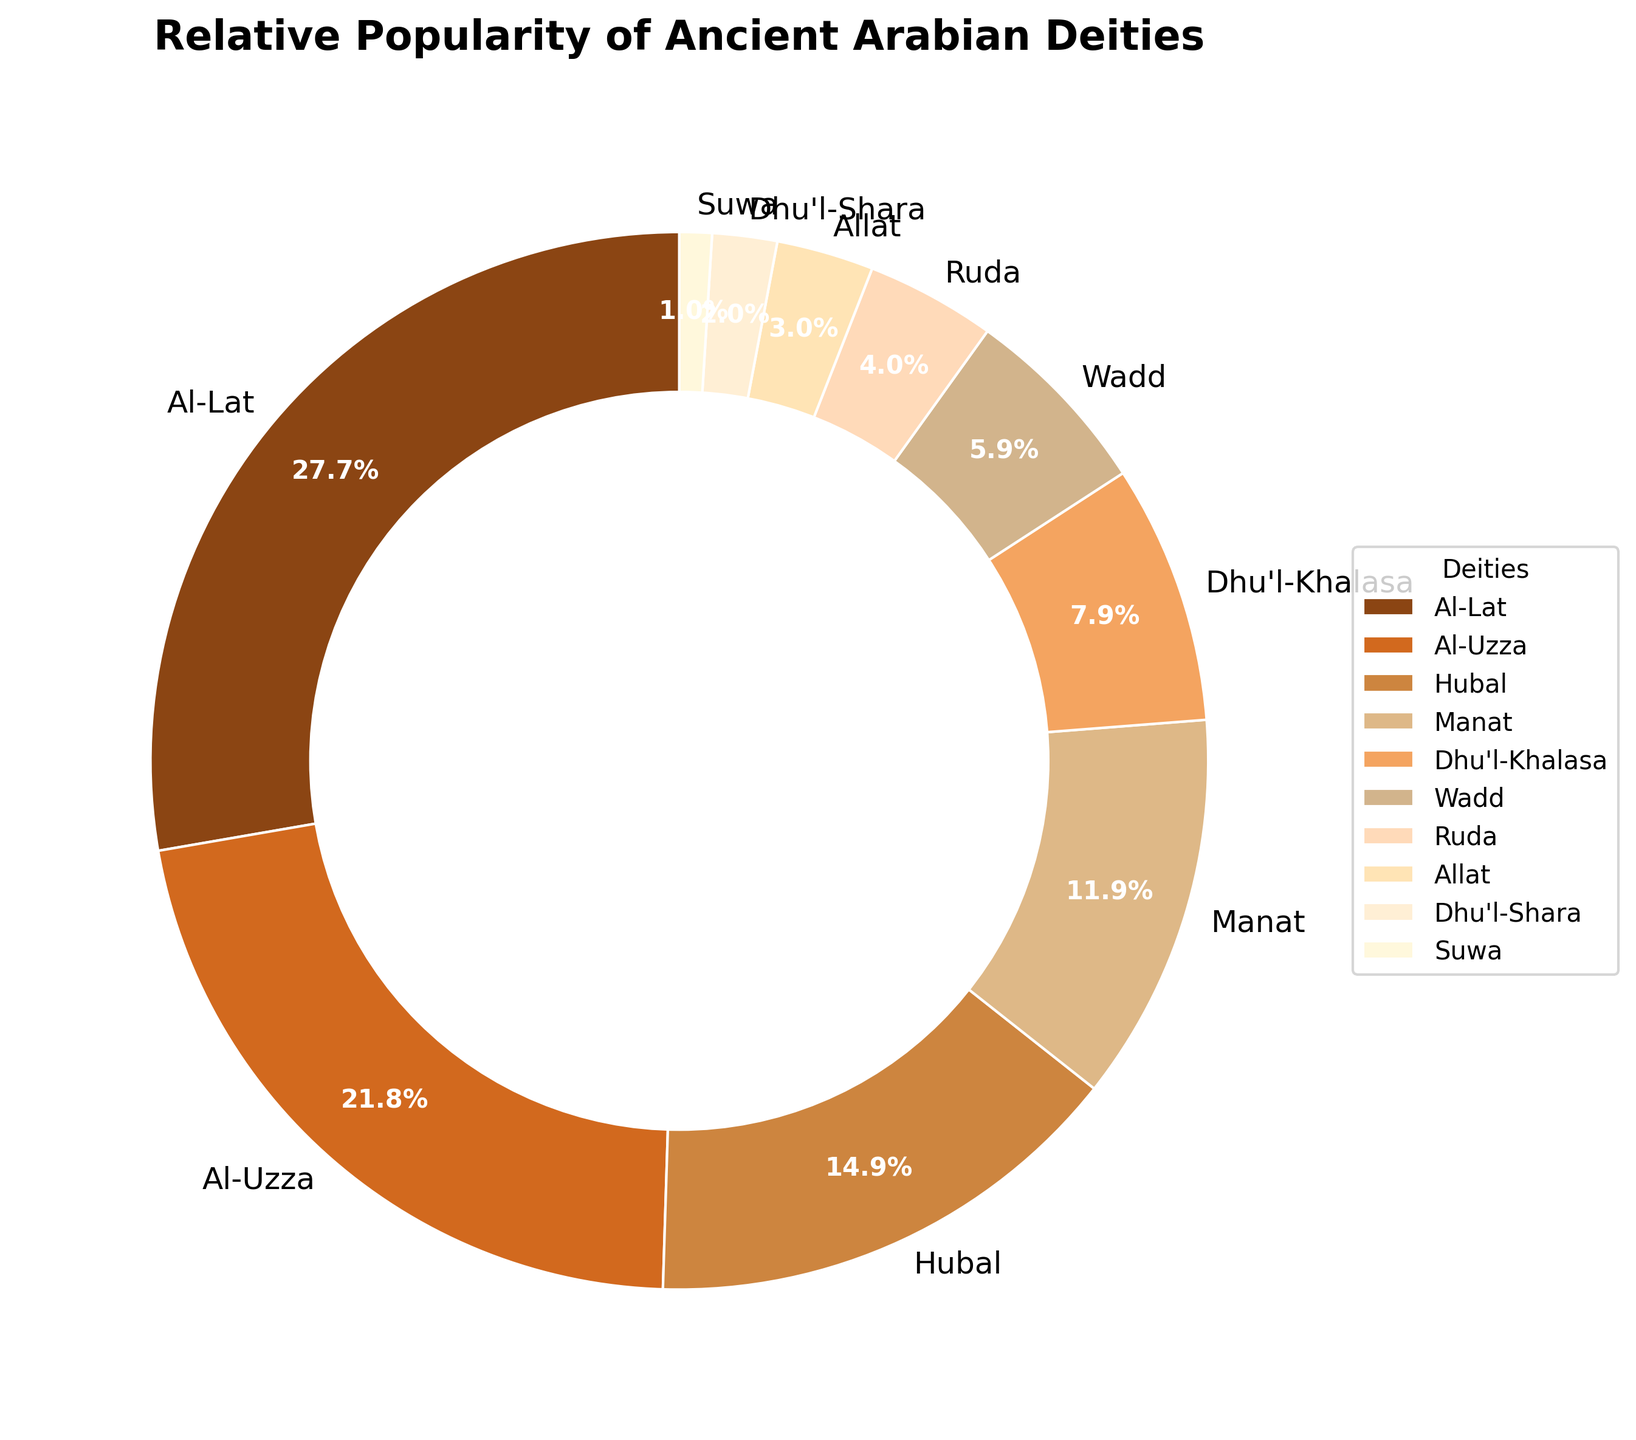What's the most popular deity according to archaeological findings? The figure shows the relative popularity of deities in a pie chart. The largest segment represents the most popular deity.
Answer: Al-Lat What's the total percentage of the four least popular deities? The least popular deities are Suwa (1%), Dhu'l-Shara (2%), Allat (3%), and Ruda (4%). Summing these percentages, 1% + 2% + 3% + 4% = 10%.
Answer: 10% Which two deities have a combined popularity that exceeds that of Hubal? Hubal has a popularity of 15%. Adding the percentages of any two deities: Al-Uzza (22%) + any other deity will exceed 15%. We can confirm this with Al-Uzza and Al-Lat, as 22% + 28% = 50%.
Answer: Al-Lat and Al-Uzza What's the difference in percentage between the second most popular deity and the fifth most popular deity? The second most popular deity is Al-Uzza (22%), and the fifth most popular deity is Dhu'l-Khalasa (8%). The difference is 22% - 8% = 14%.
Answer: 14% What color represents Wadd in the pie chart? In the pie chart, Wadd is shown with a specific color. Based on the sequence of colors provided and the order of deities, Wadd is represented by a peach color.
Answer: Peach color Which deity holds a share exactly three times that of Allat? Allat has a share of 3%. The deity with three times that share is 3% * 3 = 9%. No exact match for 9%, so we check similarly for close shares. Dhu'l-Khalasa (8%) and Ruda (4%) are checked for nearest approximate matches. Missing exact figure by data.
Answer: None directly exact How many deities have a popularity greater than or equal to 10%? Count the deities with percentages 10% or higher: Al-Lat (28%), Al-Uzza (22%), Hubal (15%), and Manat (12%), making a total of 4.
Answer: 4 What is the sum of percentages of all deities whose names start with "D"? Summing the percentages of Dhu'l-Khalasa (8%), Dhu'l-Shara (2%), leads to 8% + 2% = 10%.
Answer: 10% Which deity has a popularity just slightly higher than Ruda's and what’s their percentage? Ruda has a popularity of 4%. The next slightly higher deity is Wadd with 6%.
Answer: Wadd, 6% If the deities Al-Uzza and Manat were combined into a single entity, what would be their total percentage? Al-Uzza has 22%, and Manat has 12%. Adding these together gives 22% + 12% = 34%.
Answer: 34% 